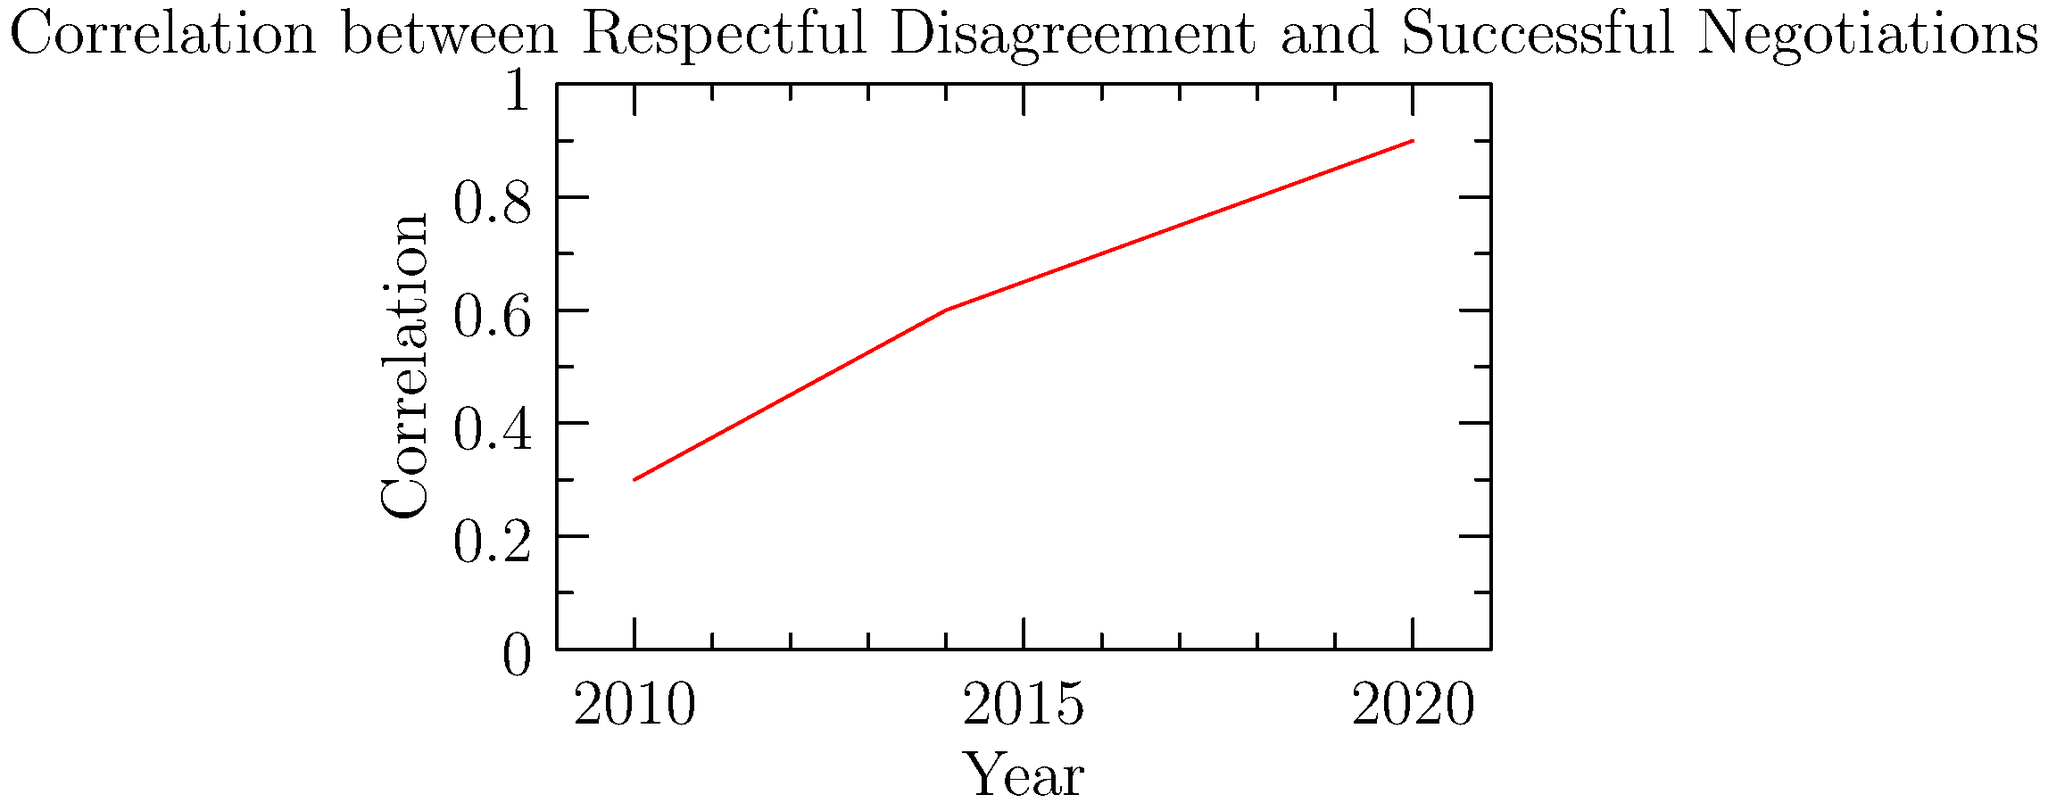Based on the line graph, what can be inferred about the relationship between respectful disagreement and successful negotiations from 2010 to 2020? To answer this question, let's analyze the graph step-by-step:

1. The x-axis represents years from 2010 to 2020.
2. The y-axis represents the correlation between respectful disagreement and successful negotiations, ranging from 0 to 1.
3. The red line shows an upward trend over time.

Let's break down the correlation values:
- 2010: approximately 0.3
- 2012: approximately 0.45
- 2014: approximately 0.6
- 2016: approximately 0.7
- 2018: approximately 0.8
- 2020: approximately 0.9

The correlation values are consistently increasing over time, which indicates a strengthening positive relationship between respectful disagreement and successful negotiations.

In correlation analysis:
- A value of 0 indicates no correlation
- Values between 0 and 1 indicate a positive correlation
- The closer the value is to 1, the stronger the positive correlation

The graph shows the correlation moving from a moderate positive correlation (0.3) in 2010 to a strong positive correlation (0.9) in 2020.

As a seasoned negotiator, this trend suggests that over time, the practice of respectful disagreement has become increasingly associated with successful negotiation outcomes.
Answer: Increasing positive correlation between respectful disagreement and successful negotiations from 2010 to 2020. 